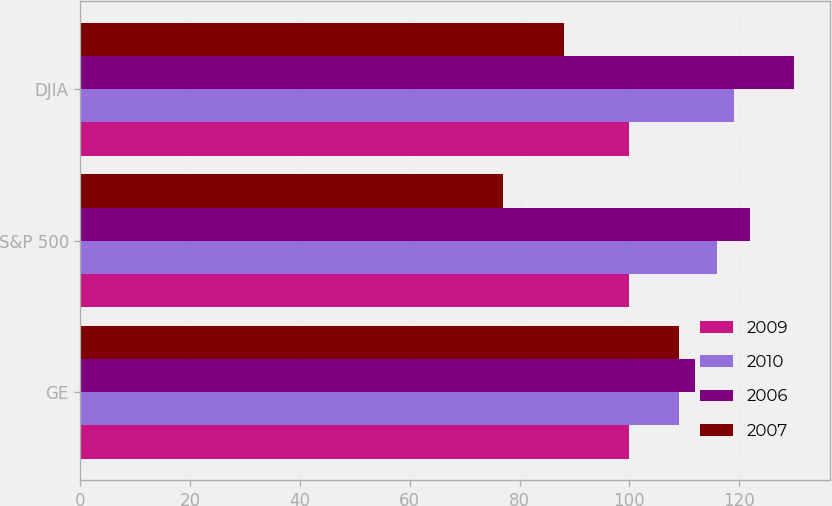<chart> <loc_0><loc_0><loc_500><loc_500><stacked_bar_chart><ecel><fcel>GE<fcel>S&P 500<fcel>DJIA<nl><fcel>2009<fcel>100<fcel>100<fcel>100<nl><fcel>2010<fcel>109<fcel>116<fcel>119<nl><fcel>2006<fcel>112<fcel>122<fcel>130<nl><fcel>2007<fcel>109<fcel>77<fcel>88<nl></chart> 